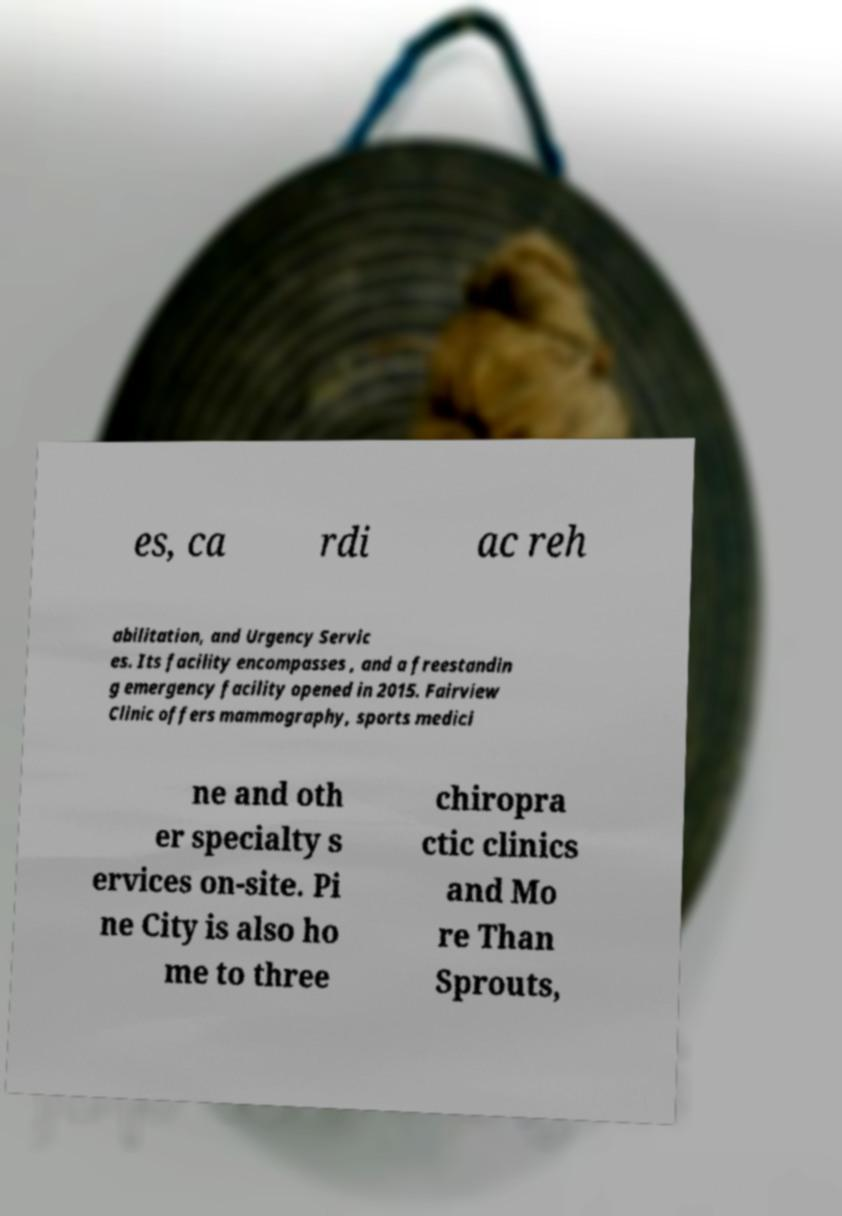What messages or text are displayed in this image? I need them in a readable, typed format. es, ca rdi ac reh abilitation, and Urgency Servic es. Its facility encompasses , and a freestandin g emergency facility opened in 2015. Fairview Clinic offers mammography, sports medici ne and oth er specialty s ervices on-site. Pi ne City is also ho me to three chiropra ctic clinics and Mo re Than Sprouts, 